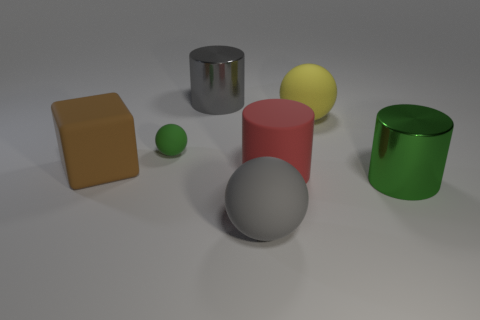The green shiny thing has what shape?
Provide a succinct answer. Cylinder. What number of large cylinders have the same color as the block?
Make the answer very short. 0. There is a gray rubber thing that is the same size as the green metal thing; what shape is it?
Your response must be concise. Sphere. Is there a gray cylinder that has the same size as the matte block?
Give a very brief answer. Yes. There is a green object that is the same size as the matte block; what is it made of?
Provide a succinct answer. Metal. There is a ball that is on the left side of the large matte sphere in front of the yellow ball; what is its size?
Provide a short and direct response. Small. There is a metal cylinder that is behind the green matte ball; does it have the same size as the big brown object?
Ensure brevity in your answer.  Yes. Are there more yellow spheres right of the green metallic cylinder than large green metal cylinders that are left of the gray shiny object?
Your response must be concise. No. What shape is the object that is both to the right of the red rubber thing and behind the green ball?
Offer a very short reply. Sphere. The green object to the right of the big gray cylinder has what shape?
Provide a succinct answer. Cylinder. 